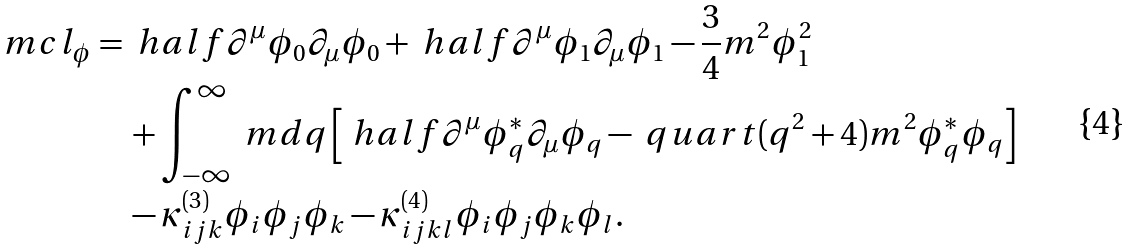Convert formula to latex. <formula><loc_0><loc_0><loc_500><loc_500>\ m c l _ { \phi } & = \ h a l f \partial ^ { \mu } \phi _ { 0 } \partial _ { \mu } \phi _ { 0 } + \ h a l f \partial ^ { \mu } \phi _ { 1 } \partial _ { \mu } \phi _ { 1 } - \frac { 3 } { 4 } m ^ { 2 } \phi _ { 1 } ^ { 2 } \\ & \quad + \int _ { - \infty } ^ { \infty } \ m d q \left [ \ h a l f \partial ^ { \mu } \phi _ { q } ^ { * } \partial _ { \mu } \phi _ { q } - \ q u a r t ( q ^ { 2 } + 4 ) m ^ { 2 } \phi _ { q } ^ { * } \phi _ { q } \right ] \\ & \quad - \kappa ^ { ( 3 ) } _ { i j k } \phi _ { i } \phi _ { j } \phi _ { k } - \kappa ^ { ( 4 ) } _ { i j k l } \phi _ { i } \phi _ { j } \phi _ { k } \phi _ { l } .</formula> 